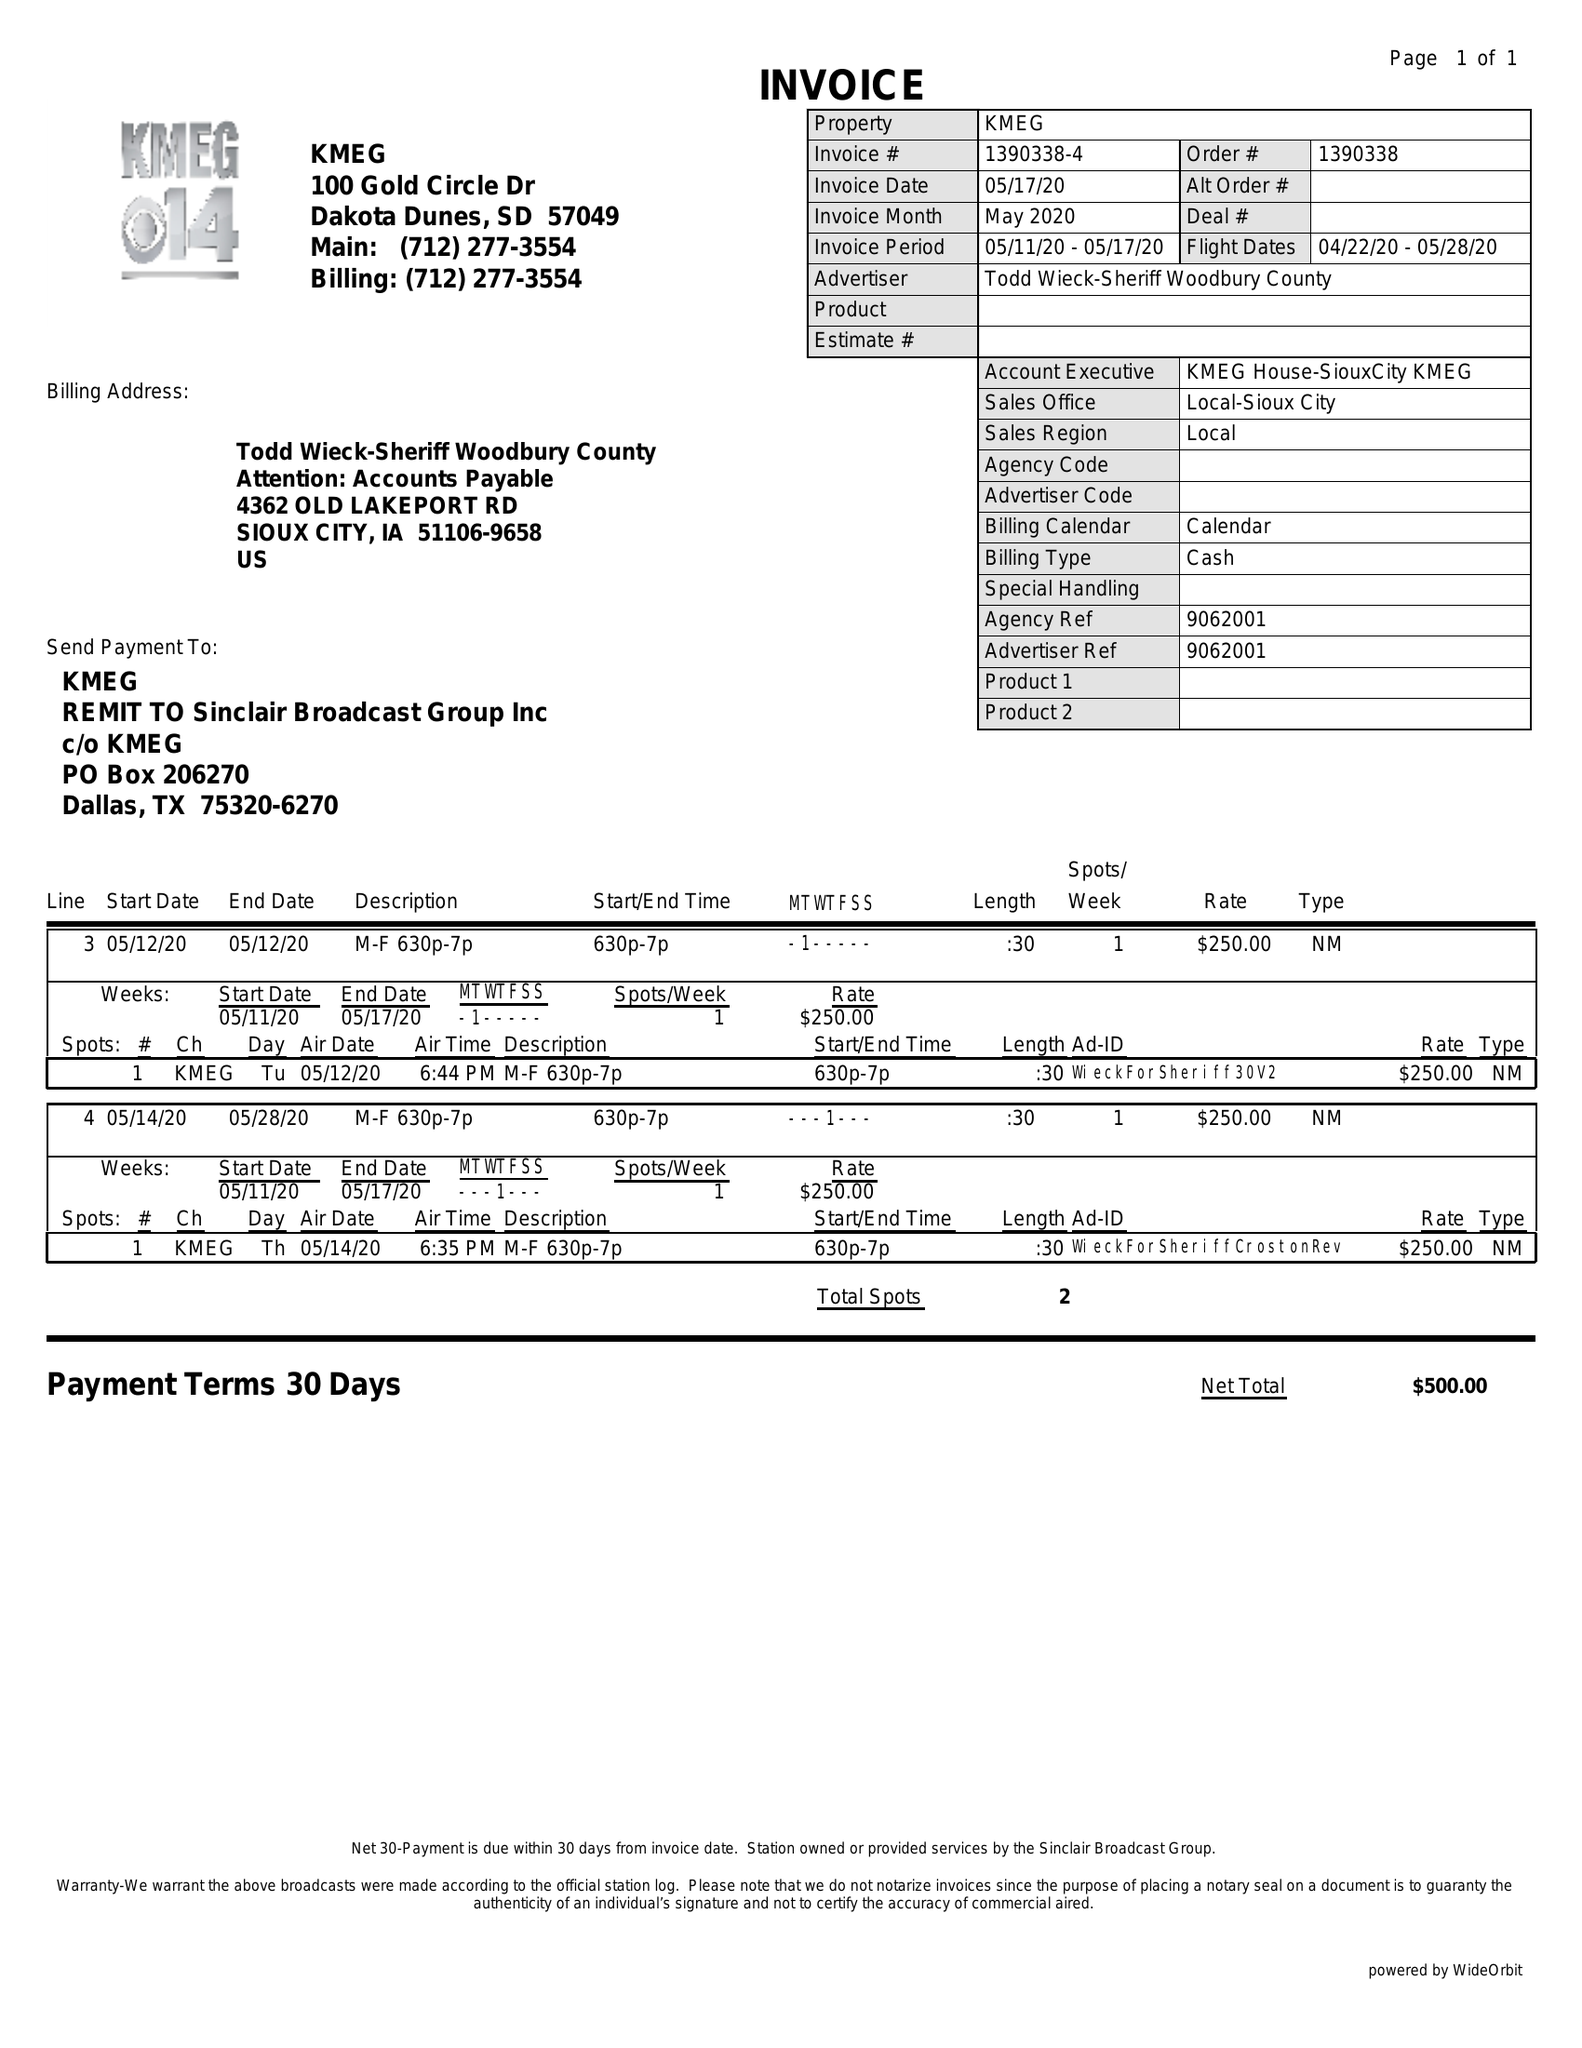What is the value for the advertiser?
Answer the question using a single word or phrase. TODD WIECK-SHERIFF WOODBURY COUNTY 